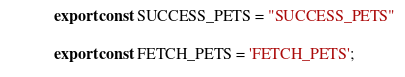Convert code to text. <code><loc_0><loc_0><loc_500><loc_500><_JavaScript_>export const SUCCESS_PETS = "SUCCESS_PETS"

export const FETCH_PETS = 'FETCH_PETS';
</code> 